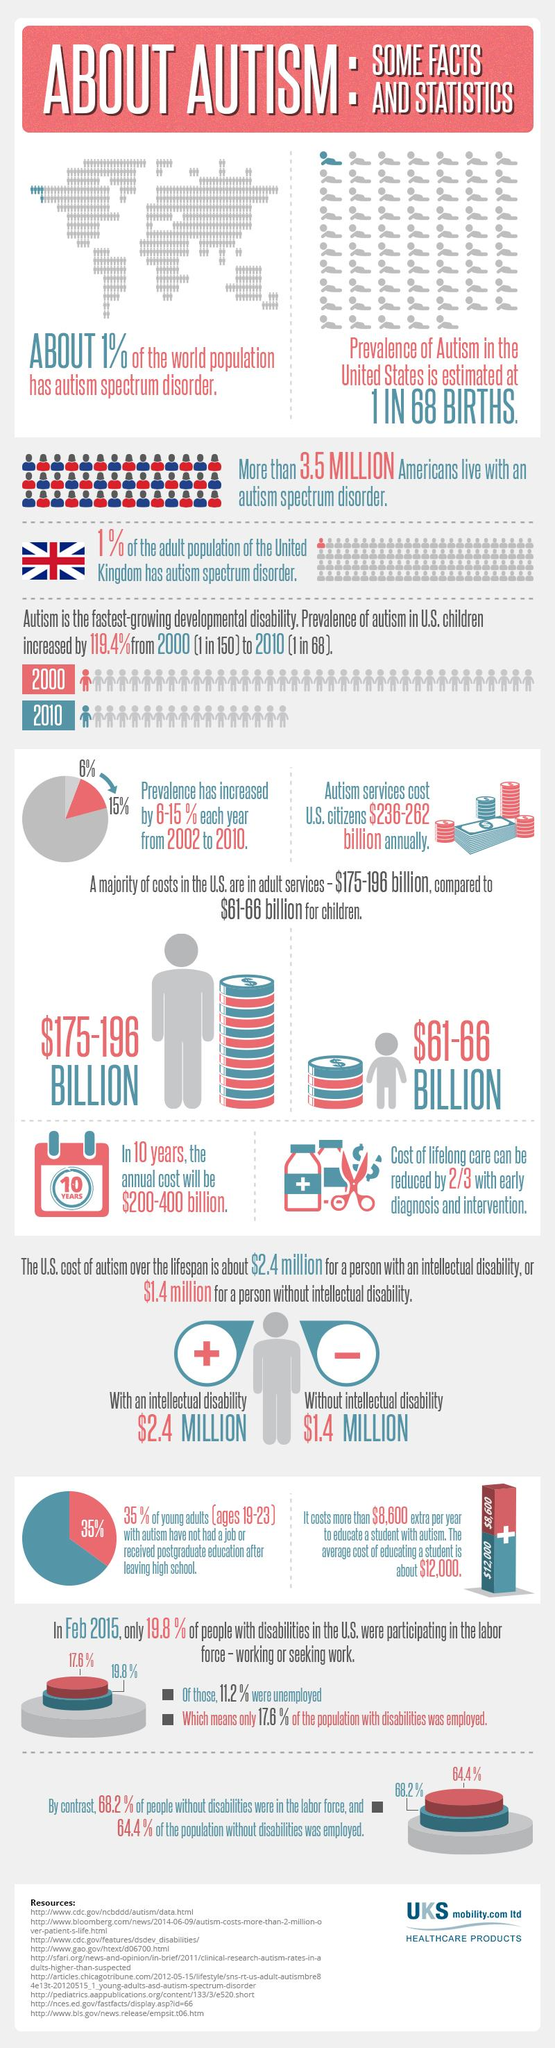Identify some key points in this picture. The percentage difference between the population without disabilities who were working and unemployed is 3.8%. In 2020, the percentage difference between the population with disabilities who were working and those who were unemployed was 6.4%. 